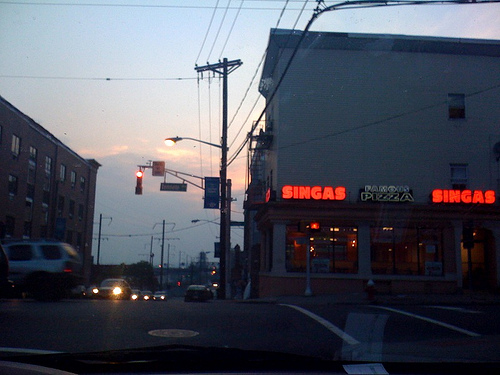Please extract the text content from this image. SINGAS PIZZA SINGAS 